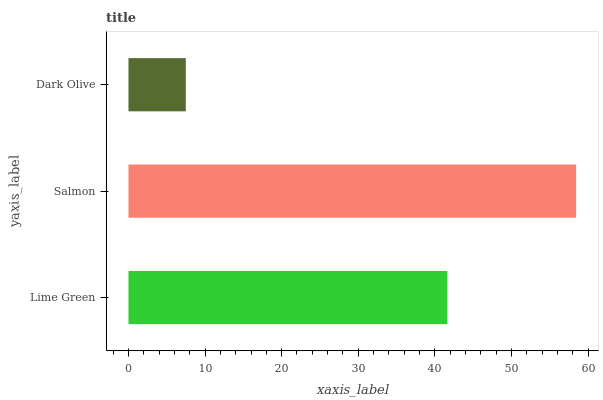Is Dark Olive the minimum?
Answer yes or no. Yes. Is Salmon the maximum?
Answer yes or no. Yes. Is Salmon the minimum?
Answer yes or no. No. Is Dark Olive the maximum?
Answer yes or no. No. Is Salmon greater than Dark Olive?
Answer yes or no. Yes. Is Dark Olive less than Salmon?
Answer yes or no. Yes. Is Dark Olive greater than Salmon?
Answer yes or no. No. Is Salmon less than Dark Olive?
Answer yes or no. No. Is Lime Green the high median?
Answer yes or no. Yes. Is Lime Green the low median?
Answer yes or no. Yes. Is Salmon the high median?
Answer yes or no. No. Is Dark Olive the low median?
Answer yes or no. No. 